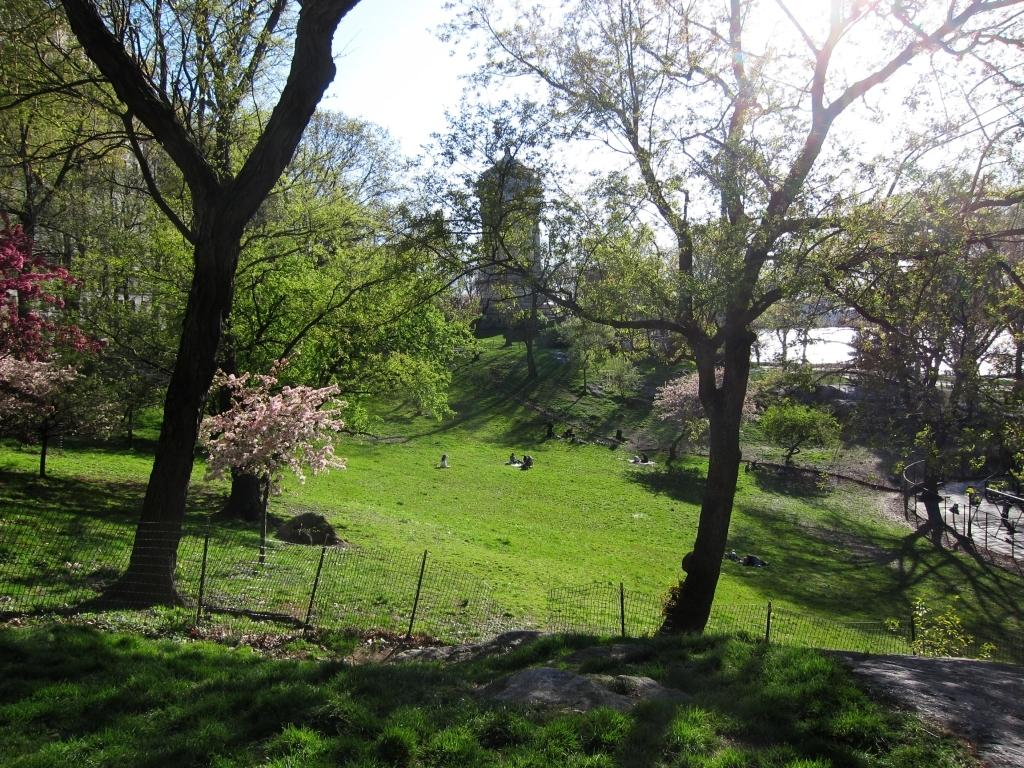What is located on the right side of the image? There is a road on the right side of the image. What can be seen in the background of the image? There are trees and water visible in the background of the image. What type of vegetation is present at the bottom of the image? There is grass on the surface at the bottom of the image. Can you tell me how many kittens are helping to build the road in the image? There are no kittens present in the image, and they are not involved in building the road. What type of fang can be seen in the water in the background of the image? There is no fang present in the image; the water in the background is not associated with any fangs. 